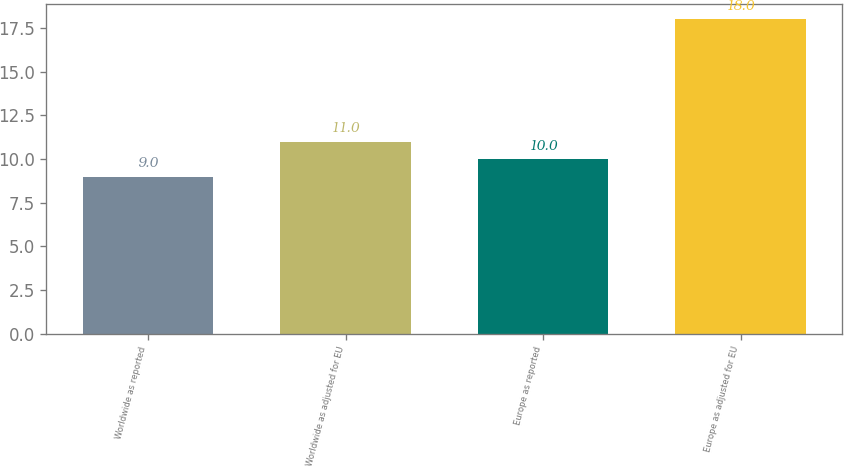Convert chart. <chart><loc_0><loc_0><loc_500><loc_500><bar_chart><fcel>Worldwide as reported<fcel>Worldwide as adjusted for EU<fcel>Europe as reported<fcel>Europe as adjusted for EU<nl><fcel>9<fcel>11<fcel>10<fcel>18<nl></chart> 